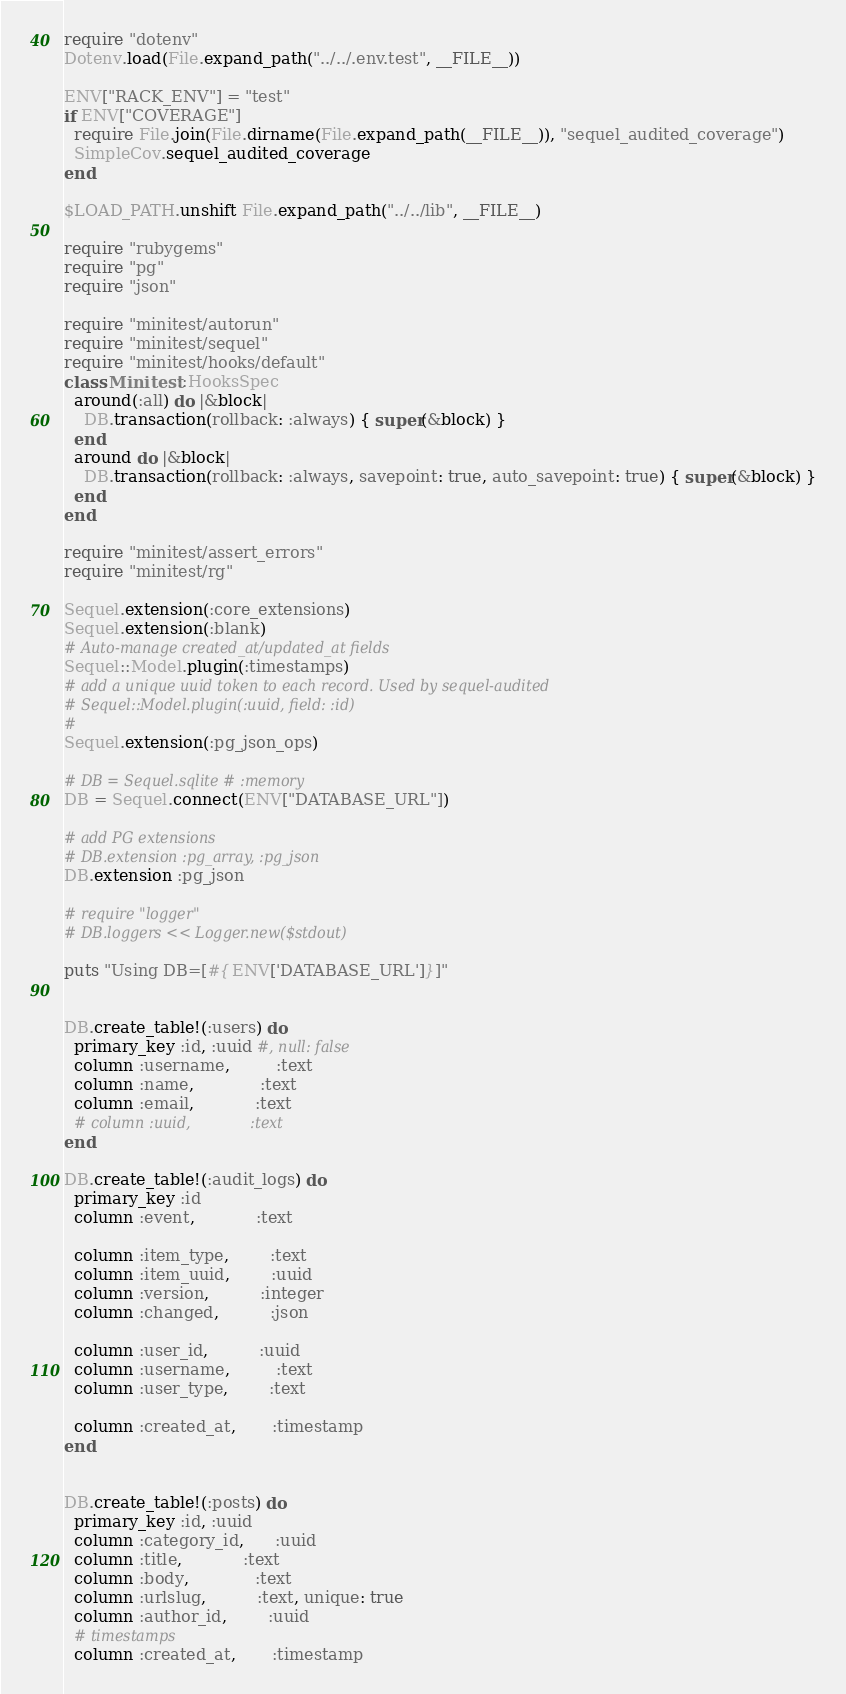Convert code to text. <code><loc_0><loc_0><loc_500><loc_500><_Ruby_>
require "dotenv"
Dotenv.load(File.expand_path("../../.env.test", __FILE__))

ENV["RACK_ENV"] = "test"
if ENV["COVERAGE"]
  require File.join(File.dirname(File.expand_path(__FILE__)), "sequel_audited_coverage")
  SimpleCov.sequel_audited_coverage
end

$LOAD_PATH.unshift File.expand_path("../../lib", __FILE__)

require "rubygems"
require "pg"
require "json"

require "minitest/autorun"
require "minitest/sequel"
require "minitest/hooks/default"
class Minitest::HooksSpec
  around(:all) do |&block|
    DB.transaction(rollback: :always) { super(&block) }
  end
  around do |&block|
    DB.transaction(rollback: :always, savepoint: true, auto_savepoint: true) { super(&block) }
  end
end

require "minitest/assert_errors"
require "minitest/rg"

Sequel.extension(:core_extensions)
Sequel.extension(:blank)
# Auto-manage created_at/updated_at fields
Sequel::Model.plugin(:timestamps)
# add a unique uuid token to each record. Used by sequel-audited
# Sequel::Model.plugin(:uuid, field: :id)
#
Sequel.extension(:pg_json_ops)

# DB = Sequel.sqlite # :memory
DB = Sequel.connect(ENV["DATABASE_URL"])

# add PG extensions
# DB.extension :pg_array, :pg_json
DB.extension :pg_json

# require "logger"
# DB.loggers << Logger.new($stdout)

puts "Using DB=[#{ENV['DATABASE_URL']}]"


DB.create_table!(:users) do
  primary_key :id, :uuid #, null: false
  column :username,         :text
  column :name,             :text
  column :email,            :text
  # column :uuid,             :text
end

DB.create_table!(:audit_logs) do
  primary_key :id
  column :event,            :text

  column :item_type,        :text
  column :item_uuid,        :uuid
  column :version,          :integer
  column :changed,          :json

  column :user_id,          :uuid
  column :username,         :text
  column :user_type,        :text

  column :created_at,       :timestamp
end


DB.create_table!(:posts) do
  primary_key :id, :uuid
  column :category_id,      :uuid
  column :title,            :text
  column :body,             :text
  column :urlslug,          :text, unique: true
  column :author_id,        :uuid
  # timestamps
  column :created_at,       :timestamp</code> 